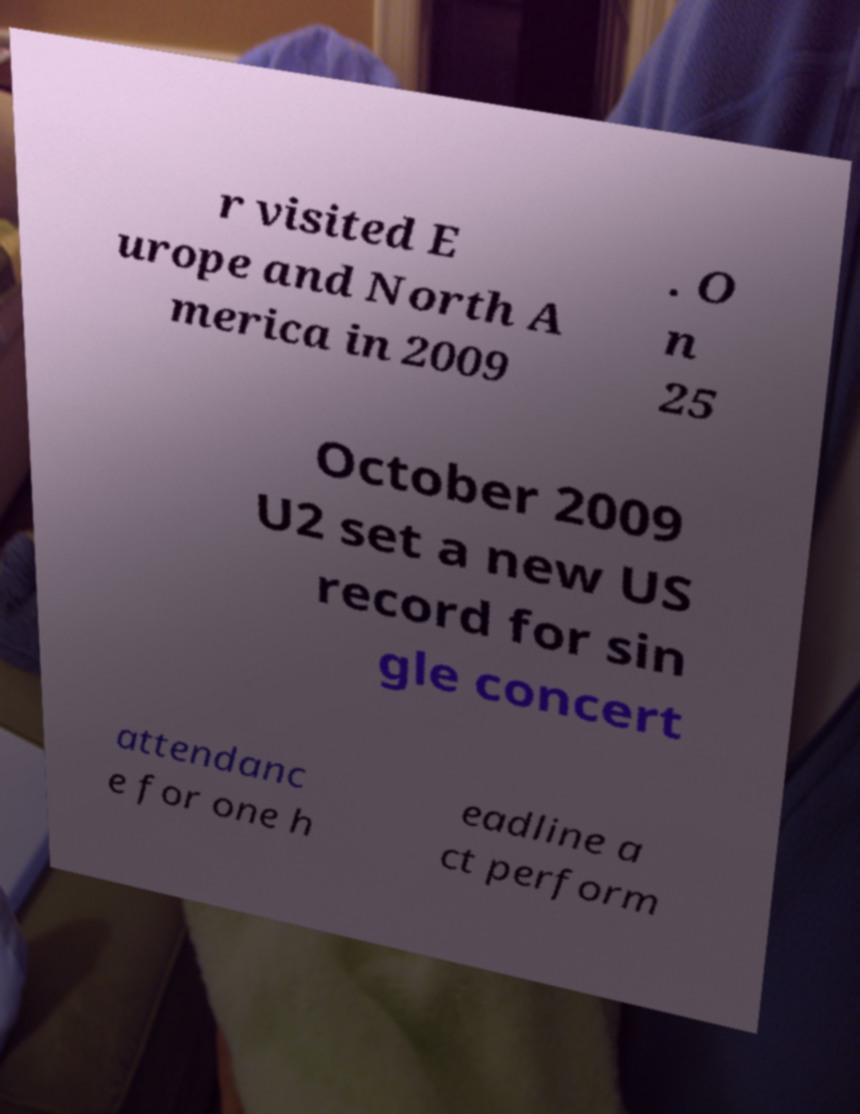Can you read and provide the text displayed in the image?This photo seems to have some interesting text. Can you extract and type it out for me? r visited E urope and North A merica in 2009 . O n 25 October 2009 U2 set a new US record for sin gle concert attendanc e for one h eadline a ct perform 